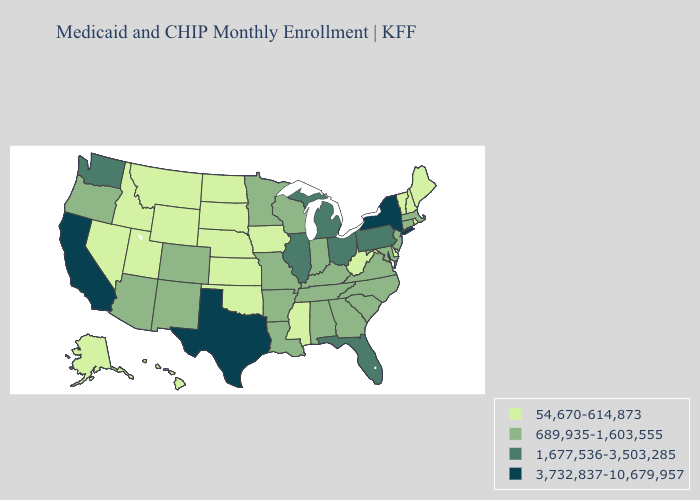What is the highest value in states that border Nebraska?
Write a very short answer. 689,935-1,603,555. Does Indiana have the same value as Wyoming?
Answer briefly. No. Among the states that border Idaho , does Washington have the lowest value?
Write a very short answer. No. What is the value of Arkansas?
Keep it brief. 689,935-1,603,555. Name the states that have a value in the range 54,670-614,873?
Concise answer only. Alaska, Delaware, Hawaii, Idaho, Iowa, Kansas, Maine, Mississippi, Montana, Nebraska, Nevada, New Hampshire, North Dakota, Oklahoma, Rhode Island, South Dakota, Utah, Vermont, West Virginia, Wyoming. Does New York have the highest value in the Northeast?
Be succinct. Yes. Does New Jersey have the lowest value in the USA?
Answer briefly. No. Does West Virginia have the lowest value in the USA?
Be succinct. Yes. What is the highest value in the West ?
Write a very short answer. 3,732,837-10,679,957. Does Louisiana have a higher value than Nevada?
Be succinct. Yes. Does Mississippi have the lowest value in the South?
Give a very brief answer. Yes. Which states have the lowest value in the USA?
Answer briefly. Alaska, Delaware, Hawaii, Idaho, Iowa, Kansas, Maine, Mississippi, Montana, Nebraska, Nevada, New Hampshire, North Dakota, Oklahoma, Rhode Island, South Dakota, Utah, Vermont, West Virginia, Wyoming. Does the map have missing data?
Give a very brief answer. No. What is the value of California?
Short answer required. 3,732,837-10,679,957. What is the value of California?
Keep it brief. 3,732,837-10,679,957. 